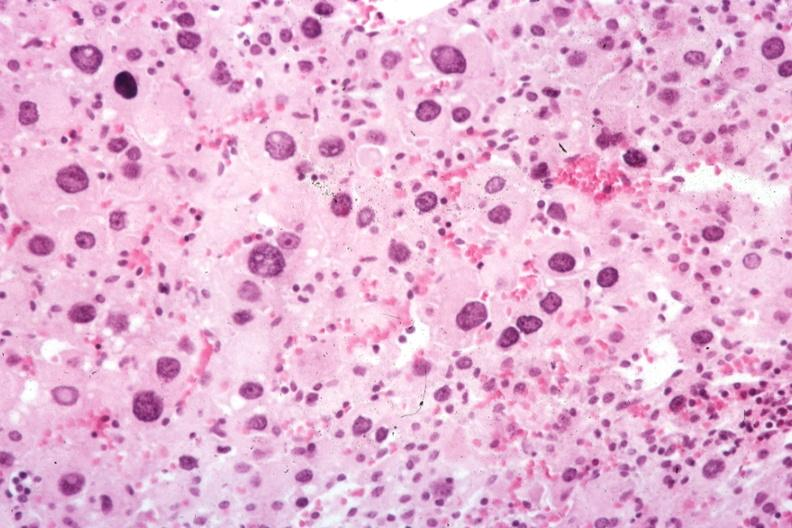s cytomegaly present?
Answer the question using a single word or phrase. Yes 